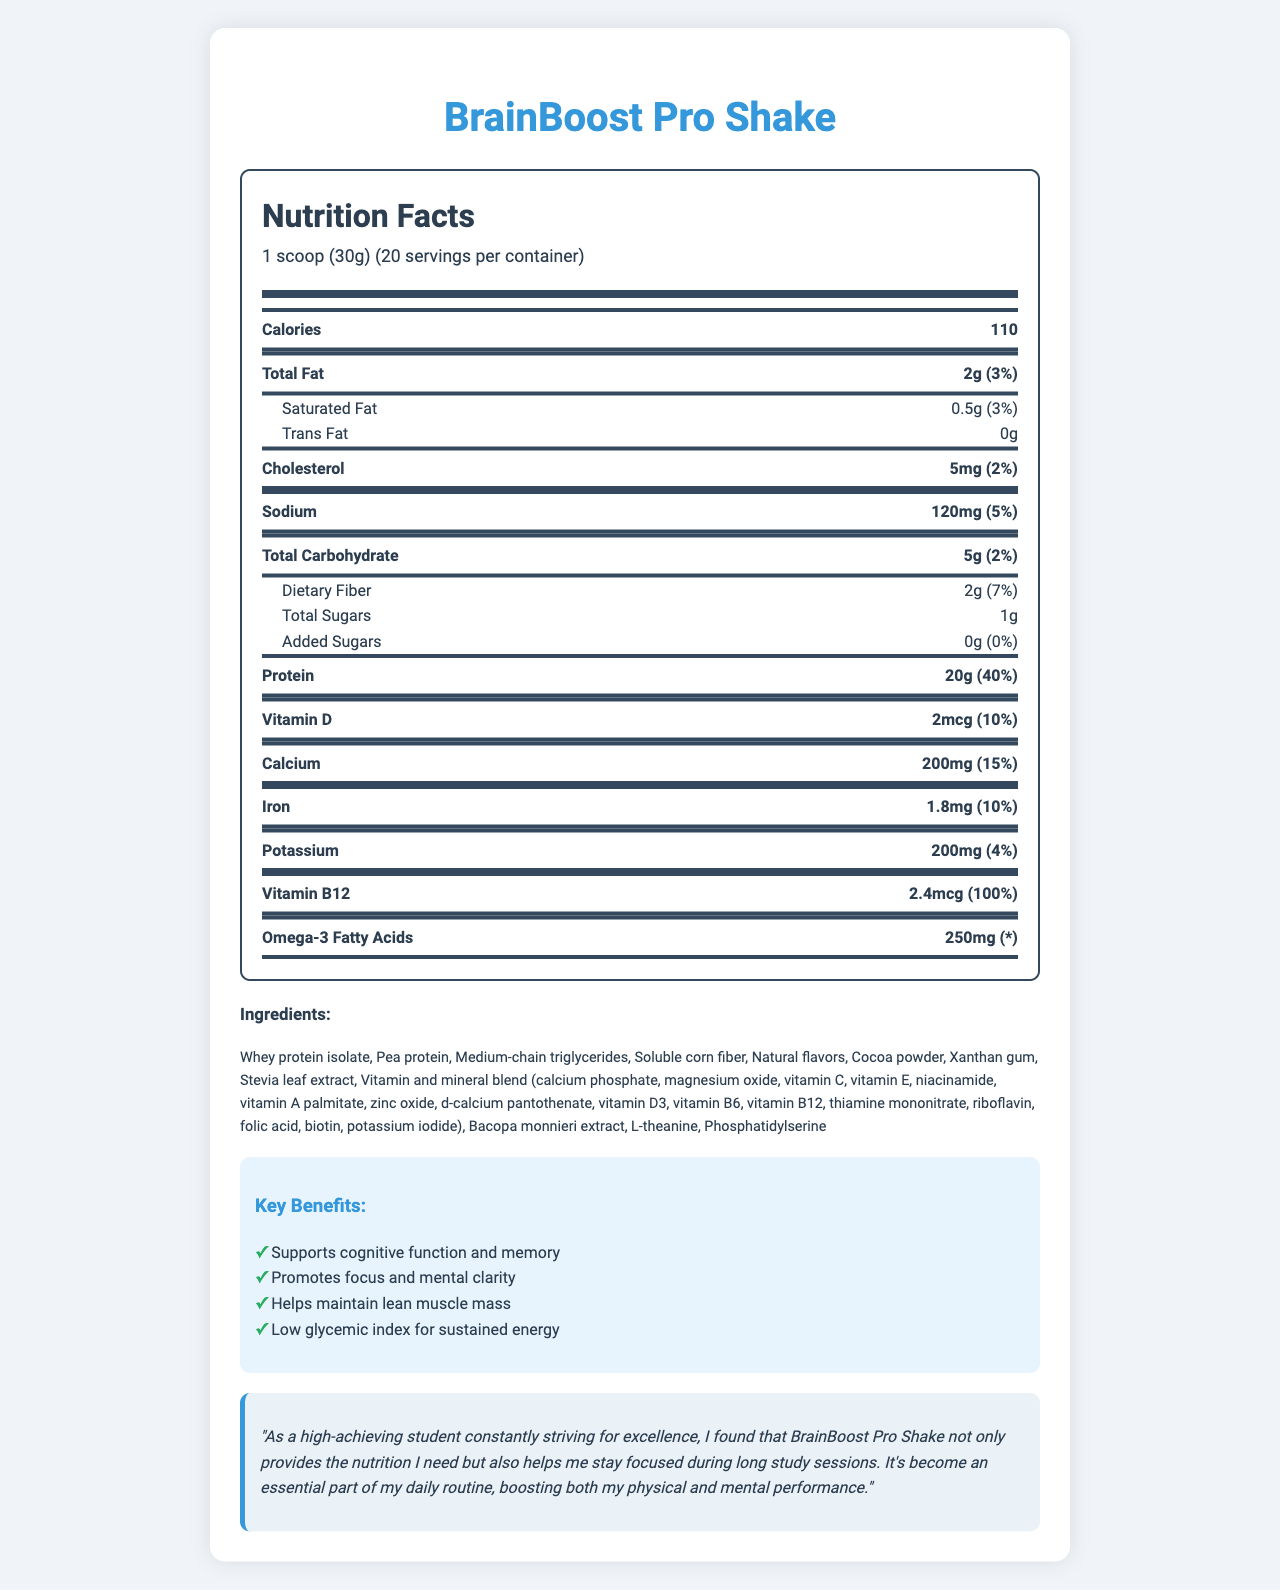what is the serving size? The serving size stated in the document is "1 scoop (30g)".
Answer: 1 scoop (30g) how many calories are there per serving? The document specifies that there are 110 calories per serving.
Answer: 110 what is the total fat content per serving? The document lists the total fat content as 2g per serving.
Answer: 2g what percentage of the daily value for protein is provided per serving? According to the document, the protein content per serving is 20g, which is 40% of the daily value.
Answer: 40% what are the main ingredients of the BrainBoost Pro Shake? The ingredients section in the document lists the main ingredients including Whey protein isolate, Pea protein, Medium-chain triglycerides, Soluble corn fiber, and others.
Answer: Whey protein isolate, Pea protein, Medium-chain triglycerides, Soluble corn fiber, and others. How many servings does a container have? A. 10 B. 15 C. 20 D. 25 The document states that there are 20 servings per container.
Answer: C. 20 Which of the following benefits is NOT claimed by the product? A. Supports cognitive function and memory B. Promotes focus and mental clarity C. Helps improve sleep quality D. Helps maintain lean muscle mass The list of claim statements does not mention improving sleep quality; it mentions supporting cognitive function and memory, promoting focus and mental clarity, and helping maintain lean muscle mass.
Answer: C. Helps improve sleep quality Does the BrainBoost Pro Shake contain any milk allergens? The allergen information section mentions that the product contains milk.
Answer: Yes Summarize the primary purpose and benefits of the BrainBoost Pro Shake. The document describes the product’s purpose as enhancing cognitive and physical performance, while also maintaining lean muscle mass and providing sustained energy.
Answer: The BrainBoost Pro Shake is a high-protein, low-calorie meal replacement designed to support cognitive function, memory, focus, and mental clarity. It aims to help maintain lean muscle mass and provides sustained energy with a low glycemic index. what is the daily value percentage of vitamin B12 provided by this shake? The nutrition facts indicate that the shake provides 100% of the daily value for vitamin B12.
Answer: 100% what is the listed price for the BrainBoost Pro Shake? The document does not include information regarding the price of the BrainBoost Pro Shake.
Answer: Cannot be determined what should you mix the shake with? The directions section advises to mix one scoop (30g) with 8-10 oz of cold water or a preferred beverage.
Answer: 8-10 oz of cold water or your favorite beverage what is the testimonial mentioned by a high-achieving student about BrainBoost Pro Shake? The testimonial from the document details that the student finds the shake helpful for both nutrition and maintaining focus during long study sessions, making it an essential part of their routine.
Answer: "As a high-achieving student constantly striving for excellence, I found that BrainBoost Pro Shake not only provides the nutrition I need but also helps me stay focused during long study sessions. It's become an essential part of my daily routine, boosting both my physical and mental performance." 